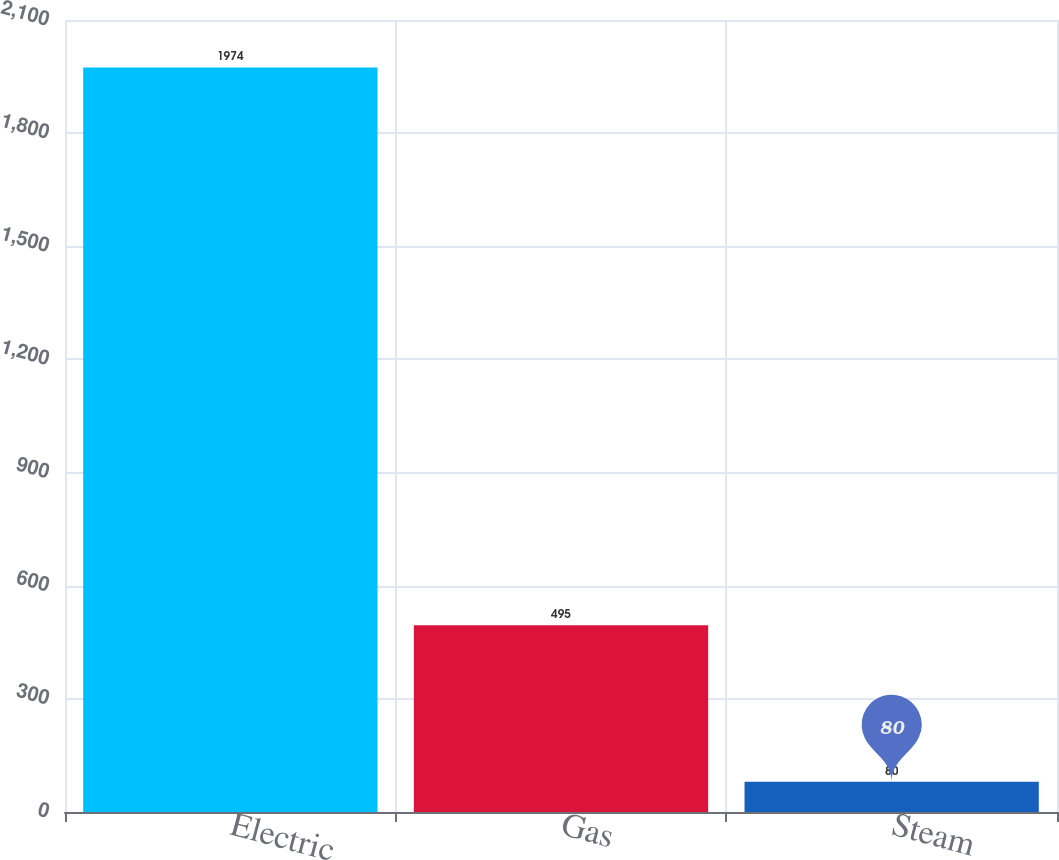Convert chart. <chart><loc_0><loc_0><loc_500><loc_500><bar_chart><fcel>Electric<fcel>Gas<fcel>Steam<nl><fcel>1974<fcel>495<fcel>80<nl></chart> 